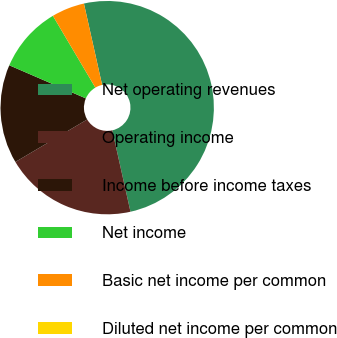Convert chart. <chart><loc_0><loc_0><loc_500><loc_500><pie_chart><fcel>Net operating revenues<fcel>Operating income<fcel>Income before income taxes<fcel>Net income<fcel>Basic net income per common<fcel>Diluted net income per common<nl><fcel>50.0%<fcel>20.0%<fcel>15.0%<fcel>10.0%<fcel>5.0%<fcel>0.0%<nl></chart> 